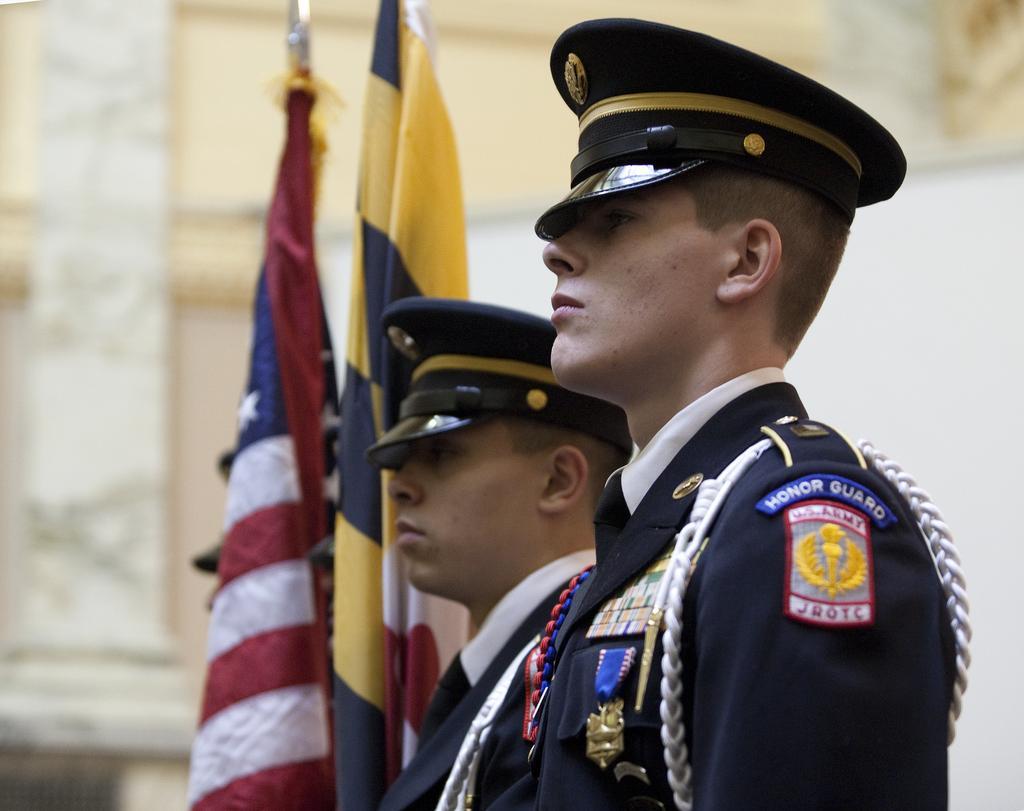Please provide a concise description of this image. In the image there are two guards,they are wearing an uniform and standing beside the two flags,there are some badges kept to their uniform. The background of the two people is blur. 